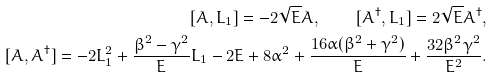<formula> <loc_0><loc_0><loc_500><loc_500>[ A , L _ { 1 } ] = - 2 \sqrt { E } A , \quad [ A ^ { \dagger } , L _ { 1 } ] = 2 \sqrt { E } A ^ { \dagger } , \\ [ A , A ^ { \dagger } ] = - 2 L _ { 1 } ^ { 2 } + \frac { \beta ^ { 2 } - \gamma ^ { 2 } } { E } L _ { 1 } - 2 E + 8 \alpha ^ { 2 } + \frac { 1 6 \alpha ( \beta ^ { 2 } + \gamma ^ { 2 } ) } { E } + \frac { 3 2 \beta ^ { 2 } \gamma ^ { 2 } } { E ^ { 2 } } .</formula> 